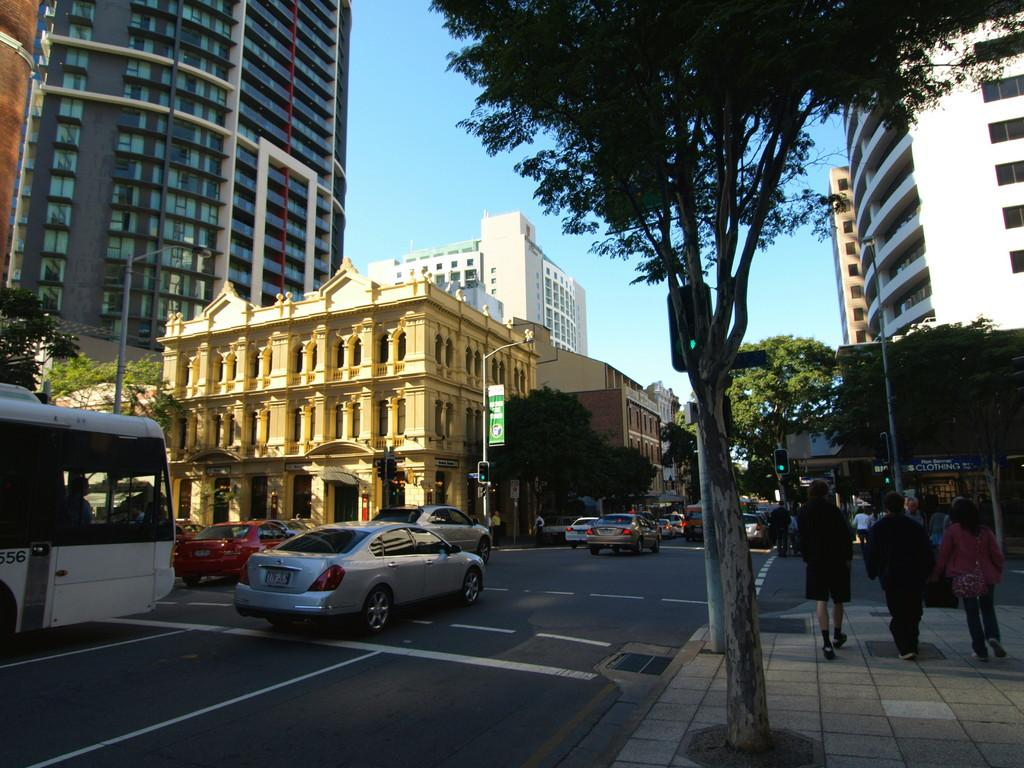What can be seen on the road in the image? There are many vehicles on the road in the image. What is present on the right side of the image? There are trees and vehicles on the footpath on the right side of the image. What can be seen on the left side of the image? There are many buildings and trees on the left side of the image. What type of straw is being used to create a harmony in the image? There is no straw or harmony present in the image; it features vehicles on the road and trees and buildings on the sides. What is being carried on the tray in the image? There is no tray present in the image. 